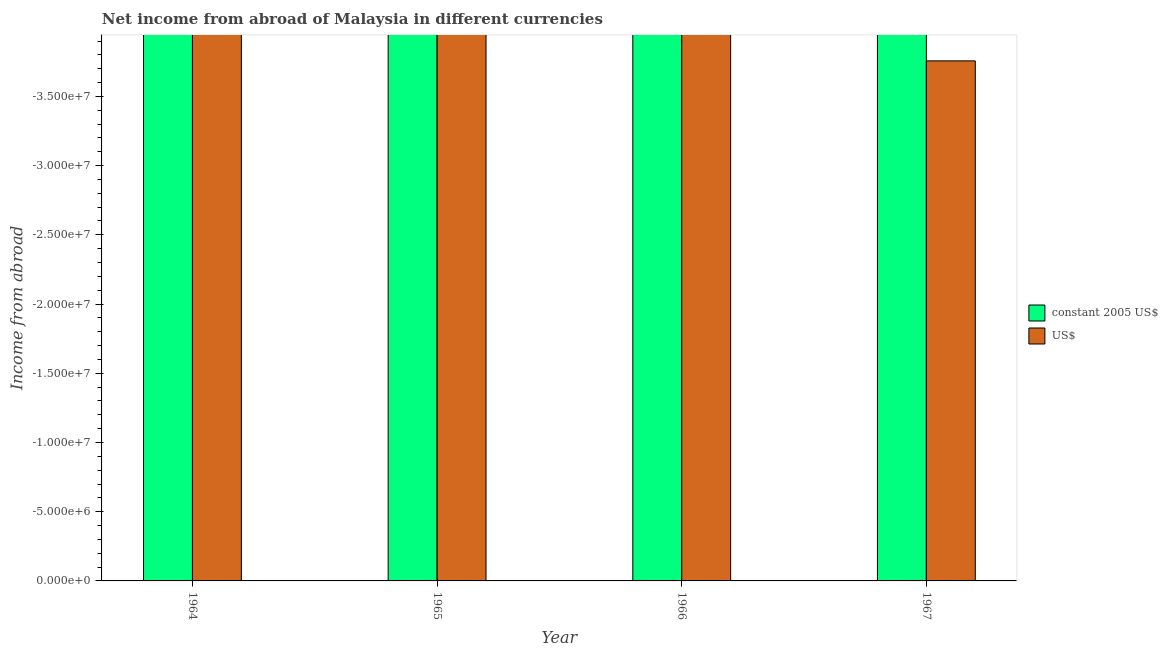Are the number of bars per tick equal to the number of legend labels?
Keep it short and to the point. No. Are the number of bars on each tick of the X-axis equal?
Give a very brief answer. Yes. What is the label of the 3rd group of bars from the left?
Provide a short and direct response. 1966. What is the difference between the income from abroad in us$ in 1964 and the income from abroad in constant 2005 us$ in 1967?
Offer a very short reply. 0. In how many years, is the income from abroad in us$ greater than the average income from abroad in us$ taken over all years?
Your response must be concise. 0. Does the graph contain any zero values?
Offer a very short reply. Yes. How many legend labels are there?
Your answer should be very brief. 2. What is the title of the graph?
Your response must be concise. Net income from abroad of Malaysia in different currencies. What is the label or title of the Y-axis?
Your response must be concise. Income from abroad. What is the Income from abroad of constant 2005 US$ in 1965?
Keep it short and to the point. 0. What is the Income from abroad of US$ in 1965?
Your response must be concise. 0. What is the Income from abroad of constant 2005 US$ in 1966?
Your response must be concise. 0. What is the total Income from abroad in constant 2005 US$ in the graph?
Your answer should be very brief. 0. What is the total Income from abroad in US$ in the graph?
Offer a terse response. 0. What is the average Income from abroad in constant 2005 US$ per year?
Make the answer very short. 0. 